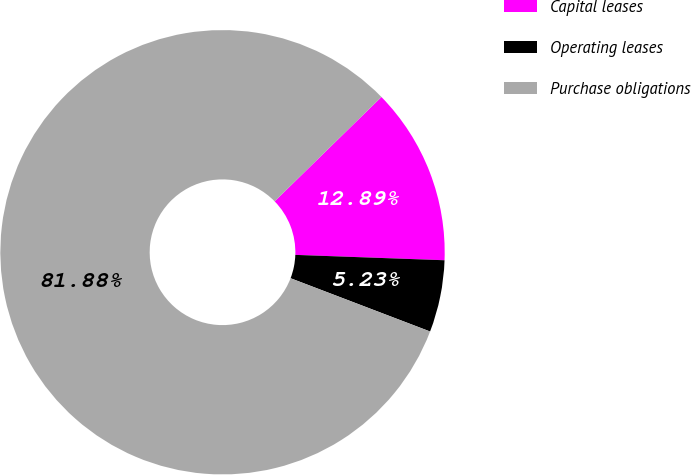Convert chart. <chart><loc_0><loc_0><loc_500><loc_500><pie_chart><fcel>Capital leases<fcel>Operating leases<fcel>Purchase obligations<nl><fcel>12.89%<fcel>5.23%<fcel>81.88%<nl></chart> 